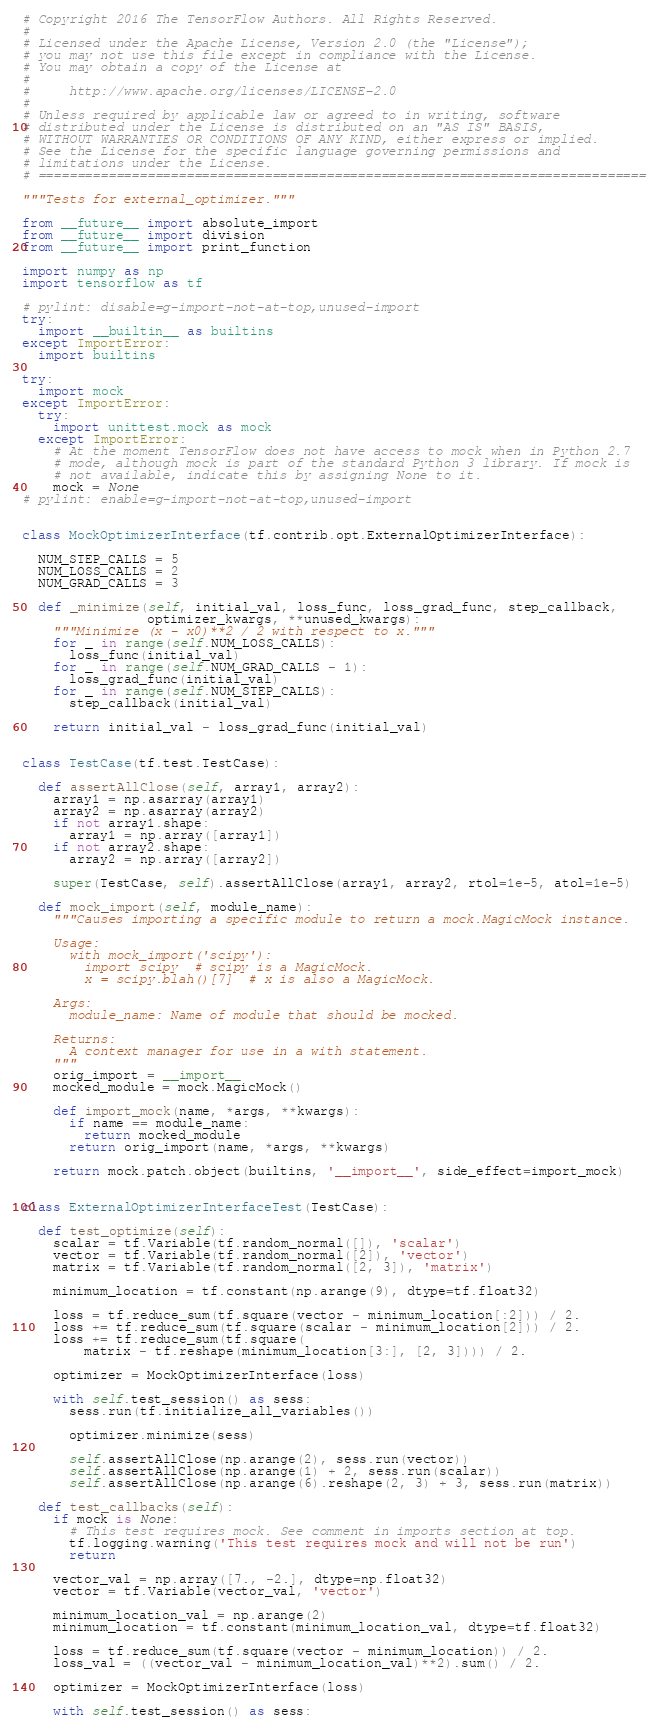Convert code to text. <code><loc_0><loc_0><loc_500><loc_500><_Python_># Copyright 2016 The TensorFlow Authors. All Rights Reserved.
#
# Licensed under the Apache License, Version 2.0 (the "License");
# you may not use this file except in compliance with the License.
# You may obtain a copy of the License at
#
#     http://www.apache.org/licenses/LICENSE-2.0
#
# Unless required by applicable law or agreed to in writing, software
# distributed under the License is distributed on an "AS IS" BASIS,
# WITHOUT WARRANTIES OR CONDITIONS OF ANY KIND, either express or implied.
# See the License for the specific language governing permissions and
# limitations under the License.
# ==============================================================================

"""Tests for external_optimizer."""

from __future__ import absolute_import
from __future__ import division
from __future__ import print_function

import numpy as np
import tensorflow as tf

# pylint: disable=g-import-not-at-top,unused-import
try:
  import __builtin__ as builtins
except ImportError:
  import builtins

try:
  import mock
except ImportError:
  try:
    import unittest.mock as mock
  except ImportError:
    # At the moment TensorFlow does not have access to mock when in Python 2.7
    # mode, although mock is part of the standard Python 3 library. If mock is
    # not available, indicate this by assigning None to it.
    mock = None
# pylint: enable=g-import-not-at-top,unused-import


class MockOptimizerInterface(tf.contrib.opt.ExternalOptimizerInterface):

  NUM_STEP_CALLS = 5
  NUM_LOSS_CALLS = 2
  NUM_GRAD_CALLS = 3

  def _minimize(self, initial_val, loss_func, loss_grad_func, step_callback,
                optimizer_kwargs, **unused_kwargs):
    """Minimize (x - x0)**2 / 2 with respect to x."""
    for _ in range(self.NUM_LOSS_CALLS):
      loss_func(initial_val)
    for _ in range(self.NUM_GRAD_CALLS - 1):
      loss_grad_func(initial_val)
    for _ in range(self.NUM_STEP_CALLS):
      step_callback(initial_val)

    return initial_val - loss_grad_func(initial_val)


class TestCase(tf.test.TestCase):

  def assertAllClose(self, array1, array2):
    array1 = np.asarray(array1)
    array2 = np.asarray(array2)
    if not array1.shape:
      array1 = np.array([array1])
    if not array2.shape:
      array2 = np.array([array2])

    super(TestCase, self).assertAllClose(array1, array2, rtol=1e-5, atol=1e-5)

  def mock_import(self, module_name):
    """Causes importing a specific module to return a mock.MagicMock instance.

    Usage:
      with mock_import('scipy'):
        import scipy  # scipy is a MagicMock.
        x = scipy.blah()[7]  # x is also a MagicMock.

    Args:
      module_name: Name of module that should be mocked.

    Returns:
      A context manager for use in a with statement.
    """
    orig_import = __import__
    mocked_module = mock.MagicMock()

    def import_mock(name, *args, **kwargs):
      if name == module_name:
        return mocked_module
      return orig_import(name, *args, **kwargs)

    return mock.patch.object(builtins, '__import__', side_effect=import_mock)


class ExternalOptimizerInterfaceTest(TestCase):

  def test_optimize(self):
    scalar = tf.Variable(tf.random_normal([]), 'scalar')
    vector = tf.Variable(tf.random_normal([2]), 'vector')
    matrix = tf.Variable(tf.random_normal([2, 3]), 'matrix')

    minimum_location = tf.constant(np.arange(9), dtype=tf.float32)

    loss = tf.reduce_sum(tf.square(vector - minimum_location[:2])) / 2.
    loss += tf.reduce_sum(tf.square(scalar - minimum_location[2])) / 2.
    loss += tf.reduce_sum(tf.square(
        matrix - tf.reshape(minimum_location[3:], [2, 3]))) / 2.

    optimizer = MockOptimizerInterface(loss)

    with self.test_session() as sess:
      sess.run(tf.initialize_all_variables())

      optimizer.minimize(sess)

      self.assertAllClose(np.arange(2), sess.run(vector))
      self.assertAllClose(np.arange(1) + 2, sess.run(scalar))
      self.assertAllClose(np.arange(6).reshape(2, 3) + 3, sess.run(matrix))

  def test_callbacks(self):
    if mock is None:
      # This test requires mock. See comment in imports section at top.
      tf.logging.warning('This test requires mock and will not be run')
      return

    vector_val = np.array([7., -2.], dtype=np.float32)
    vector = tf.Variable(vector_val, 'vector')

    minimum_location_val = np.arange(2)
    minimum_location = tf.constant(minimum_location_val, dtype=tf.float32)

    loss = tf.reduce_sum(tf.square(vector - minimum_location)) / 2.
    loss_val = ((vector_val - minimum_location_val)**2).sum() / 2.

    optimizer = MockOptimizerInterface(loss)

    with self.test_session() as sess:</code> 